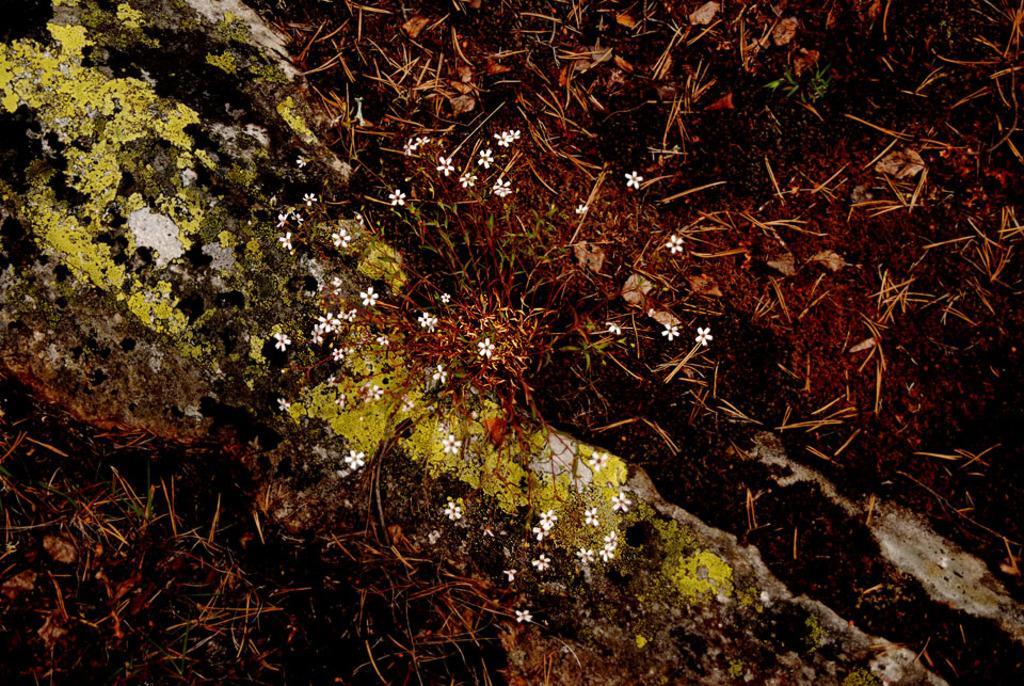Describe this image in one or two sentences. This picture seems to be clicked outside. In the center we can see the white color flowers and we can see the dry stems and some other objects. 